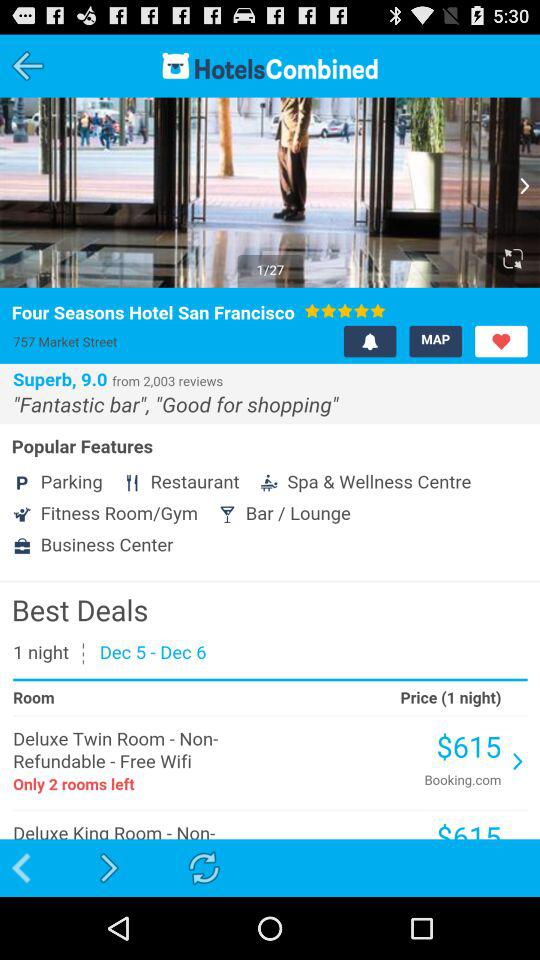What is the price of the Deluxe Twin Room?
Answer the question using a single word or phrase. $615 